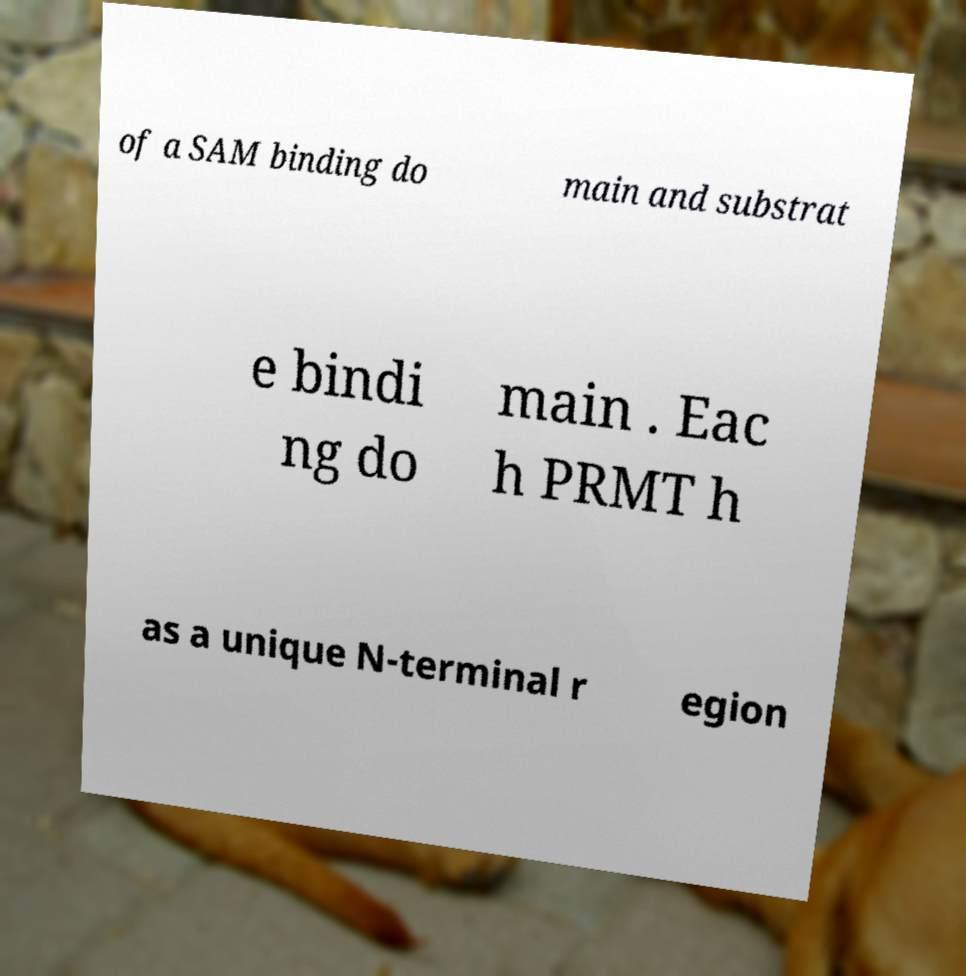Please read and relay the text visible in this image. What does it say? of a SAM binding do main and substrat e bindi ng do main . Eac h PRMT h as a unique N-terminal r egion 